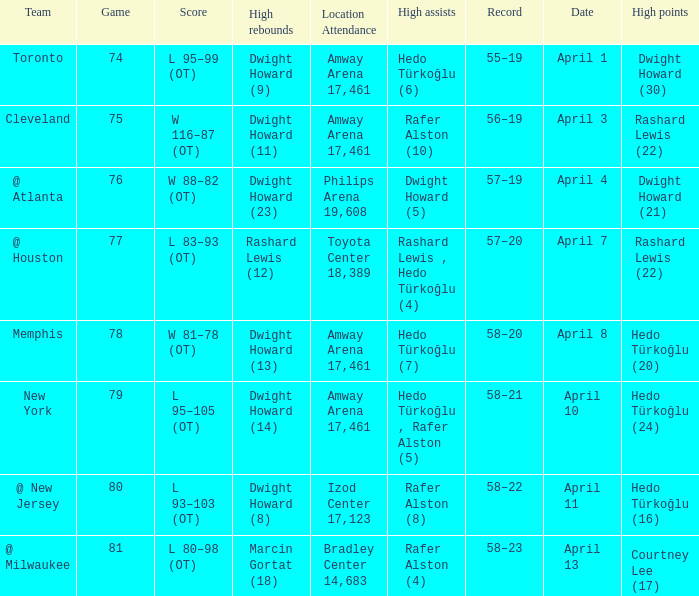Which player had the highest points in game 79? Hedo Türkoğlu (24). 